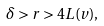<formula> <loc_0><loc_0><loc_500><loc_500>\delta > r > 4 L ( v ) ,</formula> 